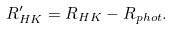Convert formula to latex. <formula><loc_0><loc_0><loc_500><loc_500>R ^ { \prime } _ { H K } = R _ { H K } - R _ { p h o t } .</formula> 